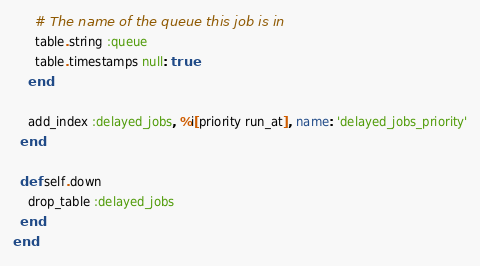<code> <loc_0><loc_0><loc_500><loc_500><_Ruby_>      # The name of the queue this job is in
      table.string :queue
      table.timestamps null: true
    end

    add_index :delayed_jobs, %i[priority run_at], name: 'delayed_jobs_priority'
  end

  def self.down
    drop_table :delayed_jobs
  end
end
</code> 